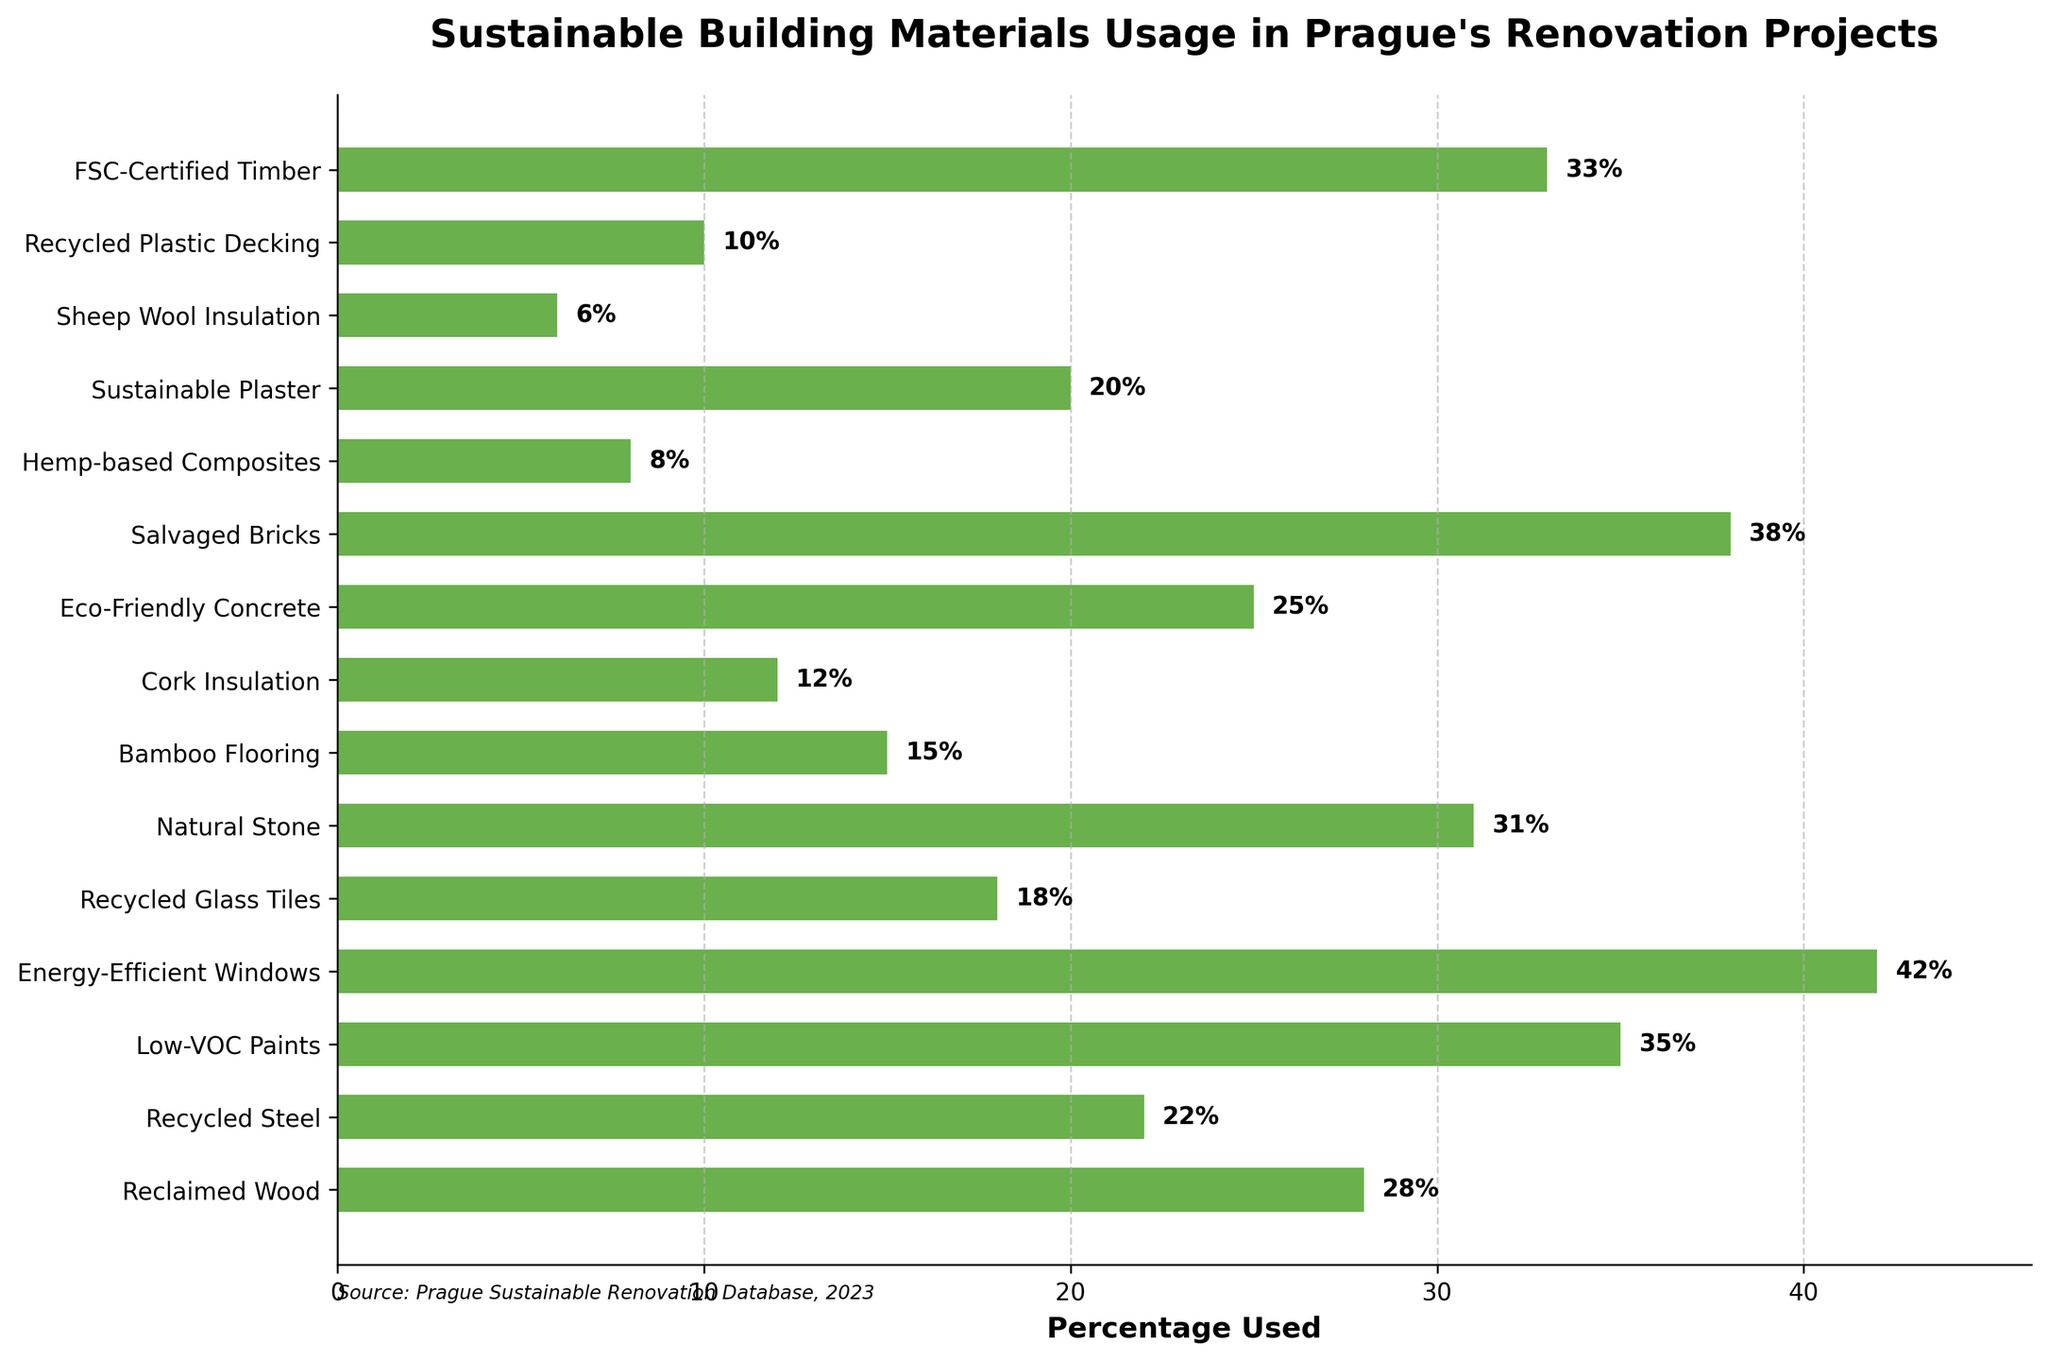Which material category is used the most in Prague's renovation projects? Look at the bar with the largest percentage value on the horizontal axis. The longest bar in the plot represents Energy-Efficient Windows at 42%.
Answer: Energy-Efficient Windows How much more percentage is used for FSC-Certified Timber compared to Cork Insulation? Find the percentages for both FSC-Certified Timber and Cork Insulation. FSC-Certified Timber is used 33% and Cork Insulation is used 12%. The difference is 33% - 12%.
Answer: 21% What is the total percentage of usage for the sustainable materials that are used less than 20%? Identify all materials with less than 20% usage: Recycled Glass Tiles (18%), Bamboo Flooring (15%), Cork Insulation (12%), Hemp-based Composites (8%), Sheep Wool Insulation (6%), Recycled Plastic Decking (10%). Sum these percentages: 18% + 15% + 12% + 8% + 6% + 10%.
Answer: 69% Which material has a higher usage percentage: Natural Stone or Eco-Friendly Concrete? Compare the lengths of the bars for Natural Stone and Eco-Friendly Concrete. Natural Stone is used at 31%, and Eco-Friendly Concrete is used at 25%.
Answer: Natural Stone What is the average percentage usage of Low-VOC Paints, Natural Stone, and Salvaged Bricks? Add the percentages of these materials and divide by the number of materials. Low-VOC Paints: 35%, Natural Stone: 31%, Salvaged Bricks: 38%. (35% + 31% + 38%) / 3.
Answer: 34.67% How does the usage of Recycled Steel compare to Reclaimed Wood? Compare the percentage values of the bars for Recycled Steel and Reclaimed Wood. Recycled Steel is 22% and Reclaimed Wood is 28%.
Answer: Reclaimed Wood Which materials have usage percentages below 10%? Identify bars with percentages less than 10%. Materials are: Hemp-based Composites (8%), Sheep Wool Insulation (6%), Recycled Plastic Decking (10%).
Answer: Hemp-based Composites, Sheep Wool Insulation What is the median value of the percentage usages of all the materials? List all percentages in ascending order and identify the middle value. List: 6%, 8%, 10%, 12%, 15%, 18%, 20%, 22%, 25%, 28%, 31%, 33%, 35%, 38%, 42%. The middle value (8th and 9th item in the sorted list) is (22% + 25%) / 2.
Answer: 23.5% Which material category has exactly 20% usage? Look for the bar labeled with 20% on the horizontal axis. It corresponds to Sustainable Plaster.
Answer: Sustainable Plaster What's the sum of usage percentages for materials used more than 30%? Identify and sum the usage percentages for materials with values greater than 30%: Low-VOC Paints (35%), Energy-Efficient Windows (42%), Natural Stone (31%), Salvaged Bricks (38%), FSC-Certified Timber (33%). 35% + 42% + 31% + 38% + 33%.
Answer: 179% 